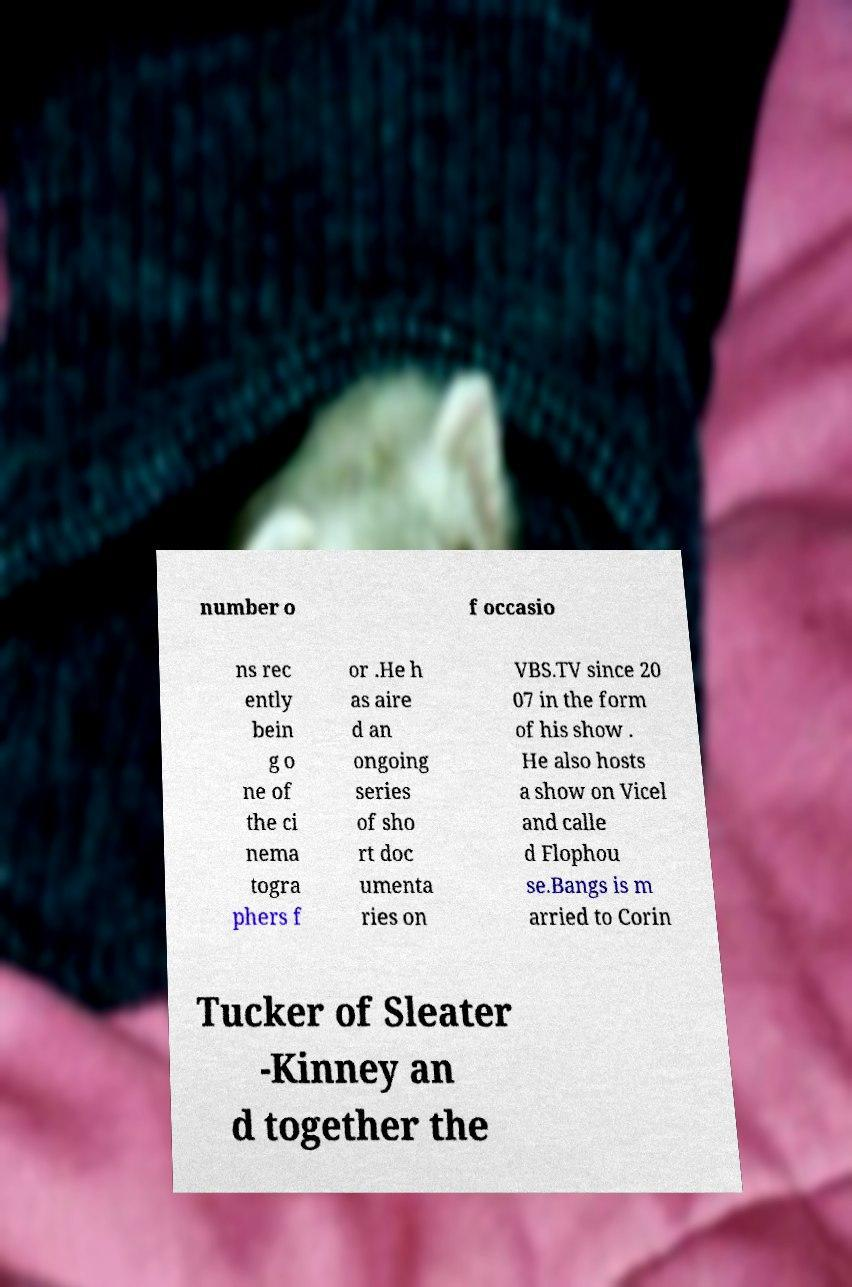Please read and relay the text visible in this image. What does it say? number o f occasio ns rec ently bein g o ne of the ci nema togra phers f or .He h as aire d an ongoing series of sho rt doc umenta ries on VBS.TV since 20 07 in the form of his show . He also hosts a show on Vicel and calle d Flophou se.Bangs is m arried to Corin Tucker of Sleater -Kinney an d together the 